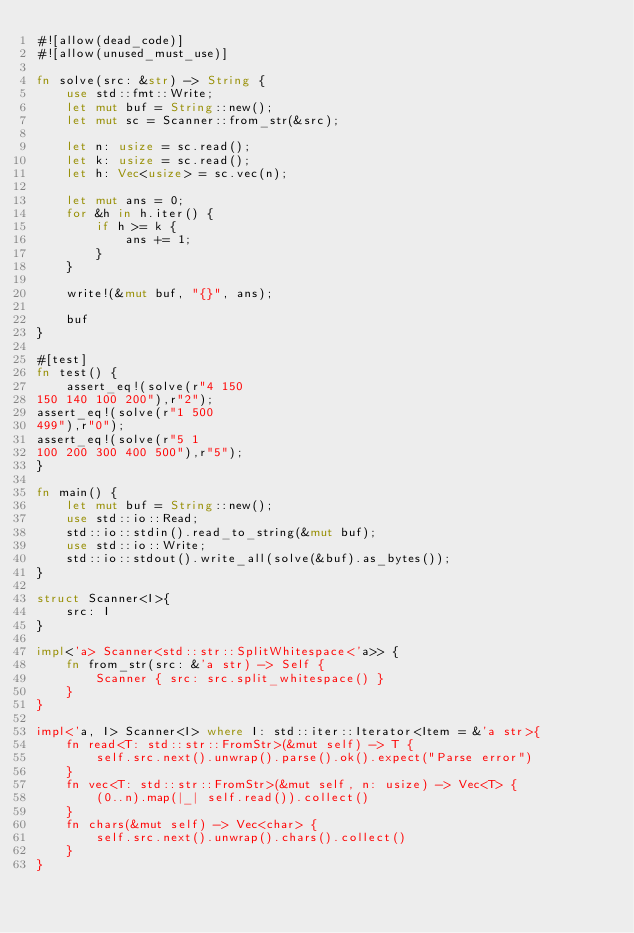Convert code to text. <code><loc_0><loc_0><loc_500><loc_500><_Rust_>#![allow(dead_code)]
#![allow(unused_must_use)]

fn solve(src: &str) -> String {
    use std::fmt::Write;
    let mut buf = String::new();
    let mut sc = Scanner::from_str(&src);

    let n: usize = sc.read();
    let k: usize = sc.read();
    let h: Vec<usize> = sc.vec(n);

    let mut ans = 0;
    for &h in h.iter() {
        if h >= k {
            ans += 1;
        }
    }

    write!(&mut buf, "{}", ans);

    buf
}

#[test]
fn test() {
    assert_eq!(solve(r"4 150
150 140 100 200"),r"2");
assert_eq!(solve(r"1 500
499"),r"0");
assert_eq!(solve(r"5 1
100 200 300 400 500"),r"5");
}

fn main() {
    let mut buf = String::new();
    use std::io::Read;
    std::io::stdin().read_to_string(&mut buf);
    use std::io::Write;
    std::io::stdout().write_all(solve(&buf).as_bytes());
}

struct Scanner<I>{
    src: I
}

impl<'a> Scanner<std::str::SplitWhitespace<'a>> {
    fn from_str(src: &'a str) -> Self {
        Scanner { src: src.split_whitespace() }
    }
}

impl<'a, I> Scanner<I> where I: std::iter::Iterator<Item = &'a str>{
    fn read<T: std::str::FromStr>(&mut self) -> T {
        self.src.next().unwrap().parse().ok().expect("Parse error")
    }
    fn vec<T: std::str::FromStr>(&mut self, n: usize) -> Vec<T> {
        (0..n).map(|_| self.read()).collect()
    }
    fn chars(&mut self) -> Vec<char> {
        self.src.next().unwrap().chars().collect()
    }
}</code> 